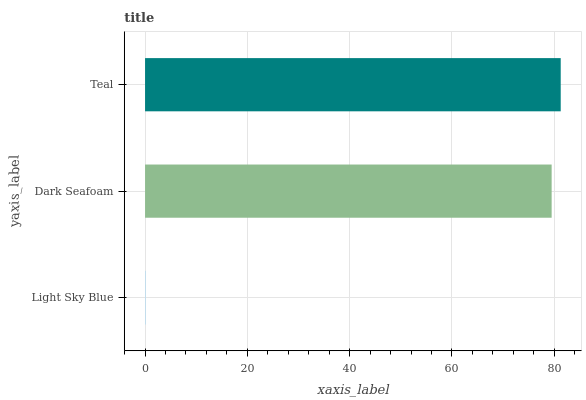Is Light Sky Blue the minimum?
Answer yes or no. Yes. Is Teal the maximum?
Answer yes or no. Yes. Is Dark Seafoam the minimum?
Answer yes or no. No. Is Dark Seafoam the maximum?
Answer yes or no. No. Is Dark Seafoam greater than Light Sky Blue?
Answer yes or no. Yes. Is Light Sky Blue less than Dark Seafoam?
Answer yes or no. Yes. Is Light Sky Blue greater than Dark Seafoam?
Answer yes or no. No. Is Dark Seafoam less than Light Sky Blue?
Answer yes or no. No. Is Dark Seafoam the high median?
Answer yes or no. Yes. Is Dark Seafoam the low median?
Answer yes or no. Yes. Is Light Sky Blue the high median?
Answer yes or no. No. Is Teal the low median?
Answer yes or no. No. 